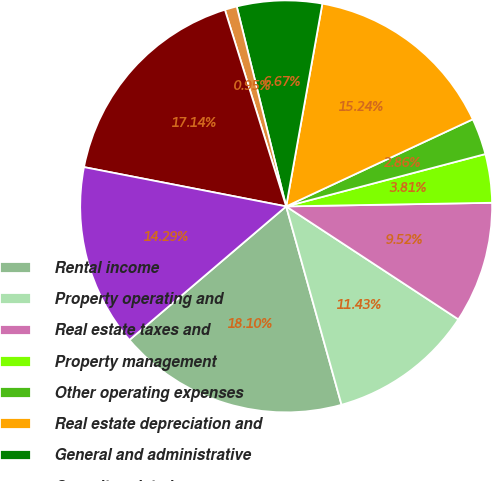Convert chart. <chart><loc_0><loc_0><loc_500><loc_500><pie_chart><fcel>Rental income<fcel>Property operating and<fcel>Real estate taxes and<fcel>Property management<fcel>Other operating expenses<fcel>Real estate depreciation and<fcel>General and administrative<fcel>Casualty-related<fcel>Total operating expenses<fcel>Operating income<nl><fcel>18.1%<fcel>11.43%<fcel>9.52%<fcel>3.81%<fcel>2.86%<fcel>15.24%<fcel>6.67%<fcel>0.95%<fcel>17.14%<fcel>14.29%<nl></chart> 